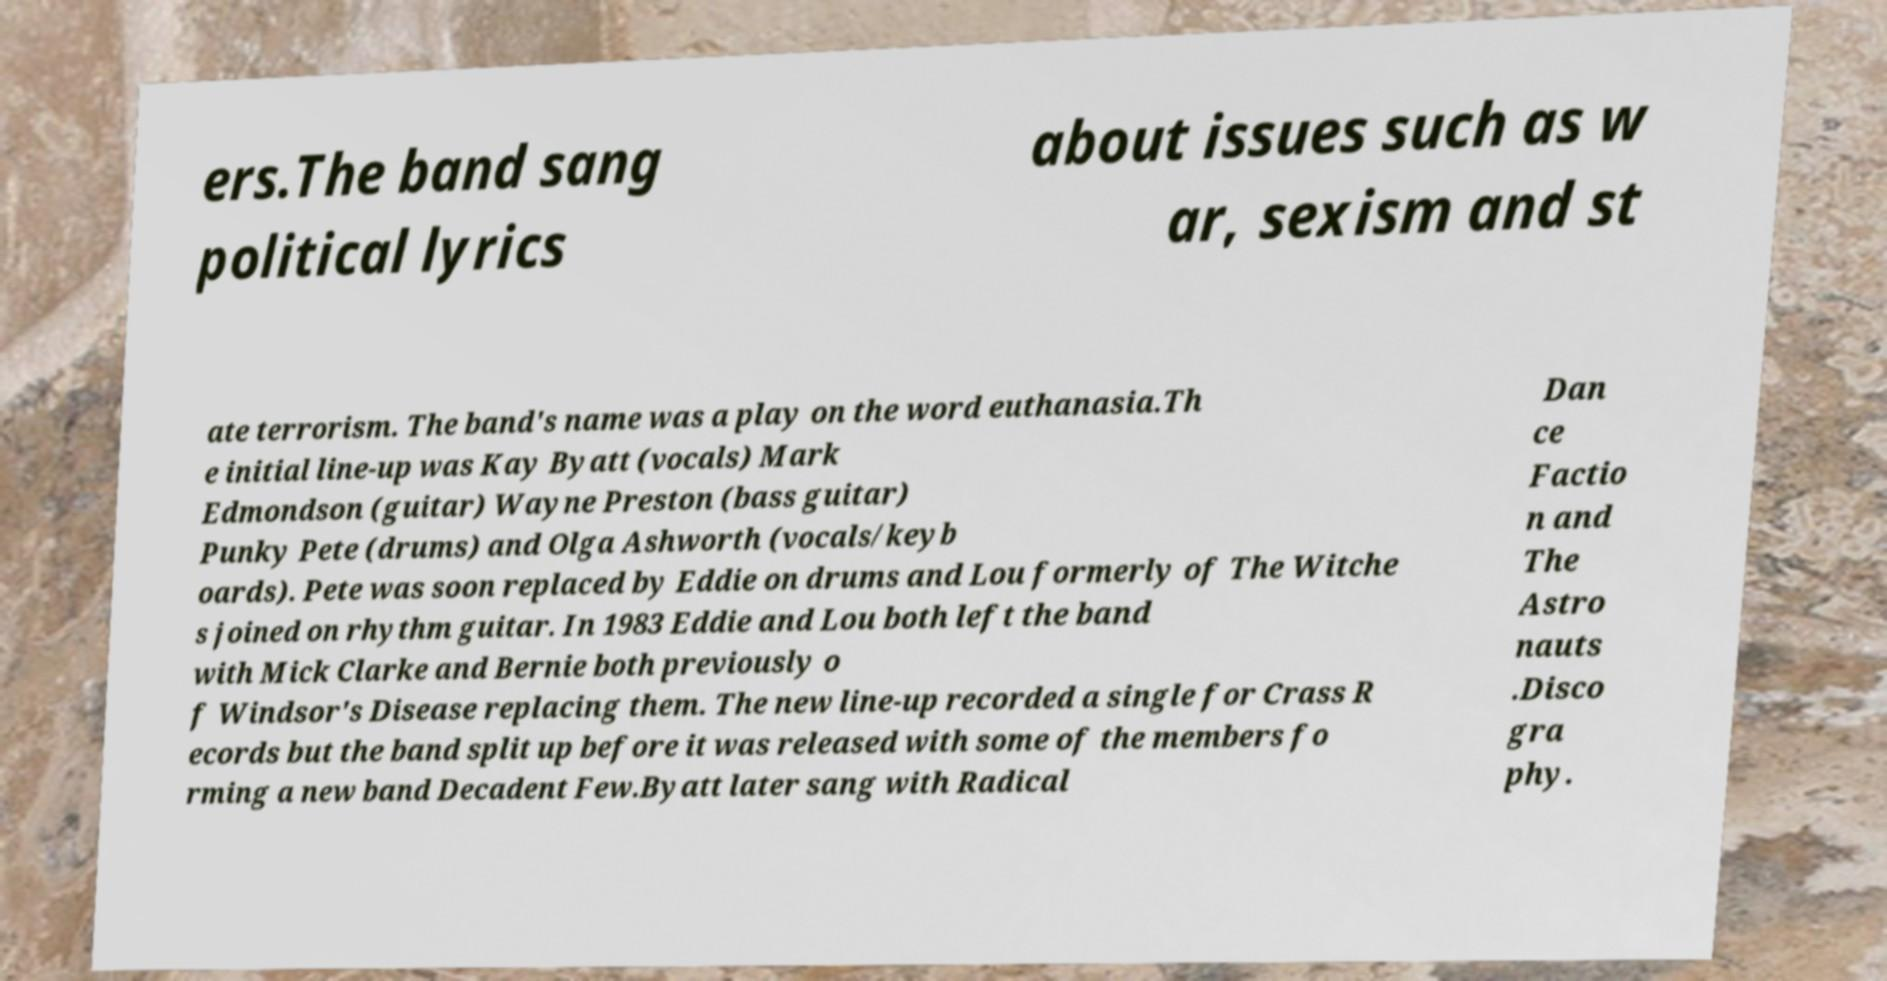There's text embedded in this image that I need extracted. Can you transcribe it verbatim? ers.The band sang political lyrics about issues such as w ar, sexism and st ate terrorism. The band's name was a play on the word euthanasia.Th e initial line-up was Kay Byatt (vocals) Mark Edmondson (guitar) Wayne Preston (bass guitar) Punky Pete (drums) and Olga Ashworth (vocals/keyb oards). Pete was soon replaced by Eddie on drums and Lou formerly of The Witche s joined on rhythm guitar. In 1983 Eddie and Lou both left the band with Mick Clarke and Bernie both previously o f Windsor's Disease replacing them. The new line-up recorded a single for Crass R ecords but the band split up before it was released with some of the members fo rming a new band Decadent Few.Byatt later sang with Radical Dan ce Factio n and The Astro nauts .Disco gra phy. 